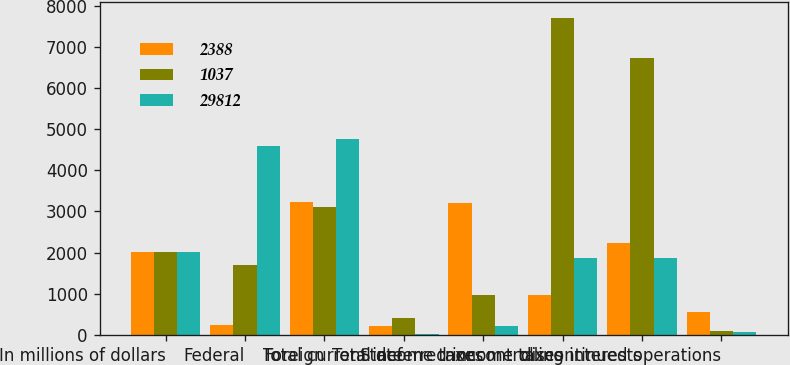Convert chart to OTSL. <chart><loc_0><loc_0><loc_500><loc_500><stacked_bar_chart><ecel><fcel>In millions of dollars<fcel>Federal<fcel>Foreign<fcel>State<fcel>Total current income taxes<fcel>Total deferred income taxes<fcel>noncontrolling interests<fcel>discontinued operations<nl><fcel>2388<fcel>2010<fcel>249<fcel>3239<fcel>207<fcel>3197<fcel>964<fcel>2233<fcel>562<nl><fcel>1037<fcel>2009<fcel>1711<fcel>3101<fcel>414<fcel>976<fcel>7709<fcel>6733<fcel>106<nl><fcel>29812<fcel>2008<fcel>4582<fcel>4762<fcel>29<fcel>209<fcel>1859.5<fcel>1859.5<fcel>79<nl></chart> 